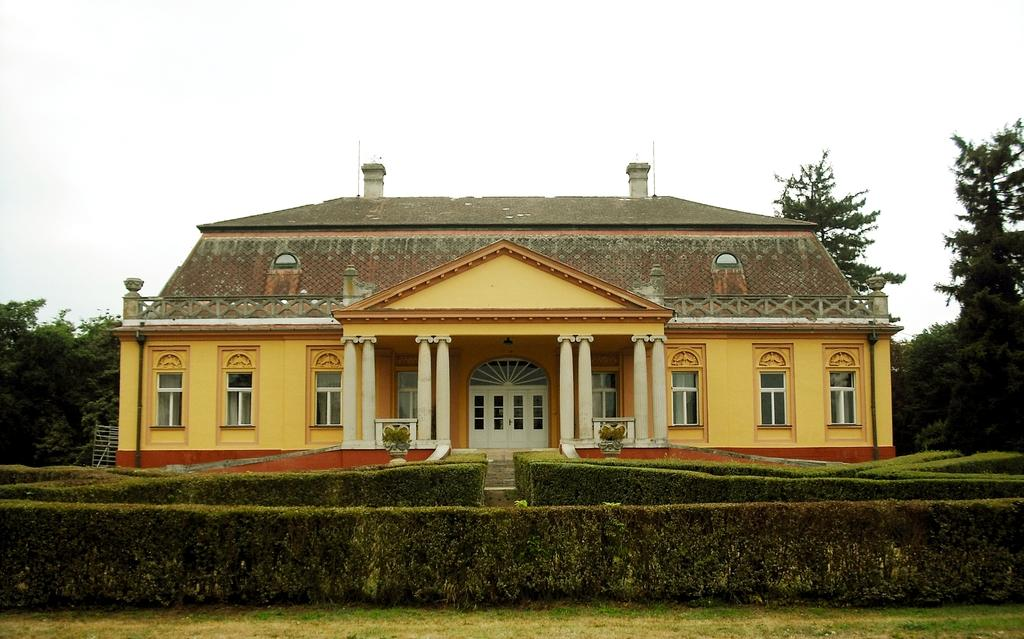What type of structure is visible in the image? There is a house in the image. What is in front of the house? There are hedges in front of the house. What type of vegetation is on the ground at the bottom of the image? There is grass on the ground at the bottom of the image. What is located behind the house? There are trees behind the house. What is visible at the top of the image? The sky is visible at the top of the image. Can you hear the kitten coughing in the image? There is no kitten or any sound present in the image, as it is a still image. 